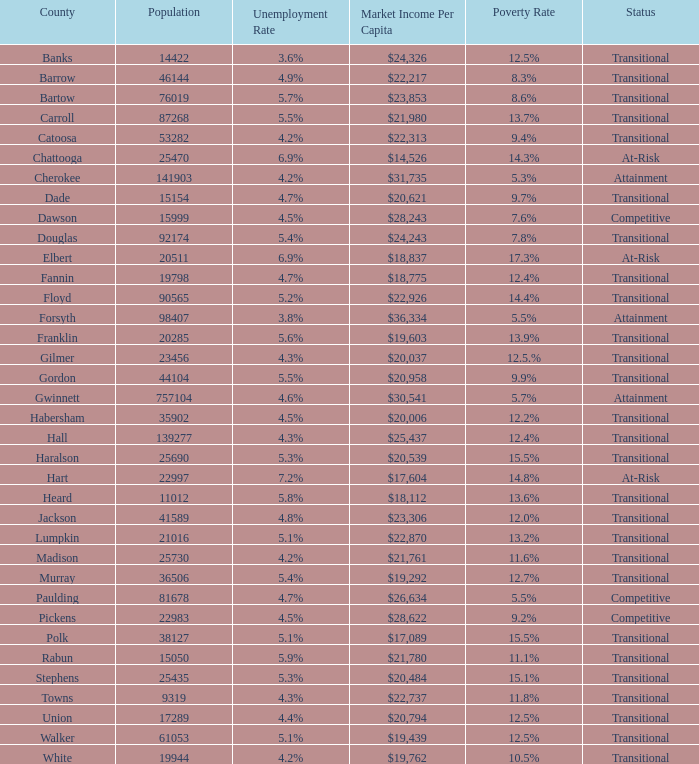What is the market income for each person in the county with a poverty rate of $22,313. 